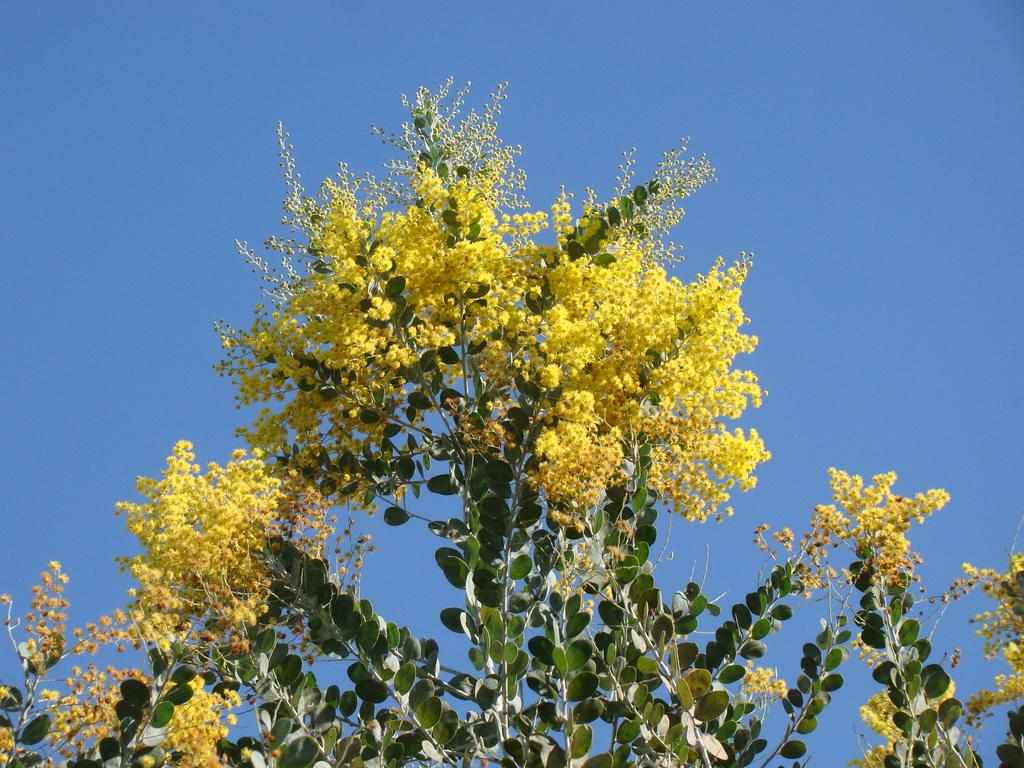What type of plant can be seen in the image? There is a tree in the image. How is the tree depicted in the image? The tree is truncated. Are there any additional features on the tree? Yes, there are flowers on the tree. What is visible in the background of the image? The sky is visible in the image. Where is the hook attached to the tree in the image? There is no hook present in the image; it only features a tree with flowers and a truncated appearance. 